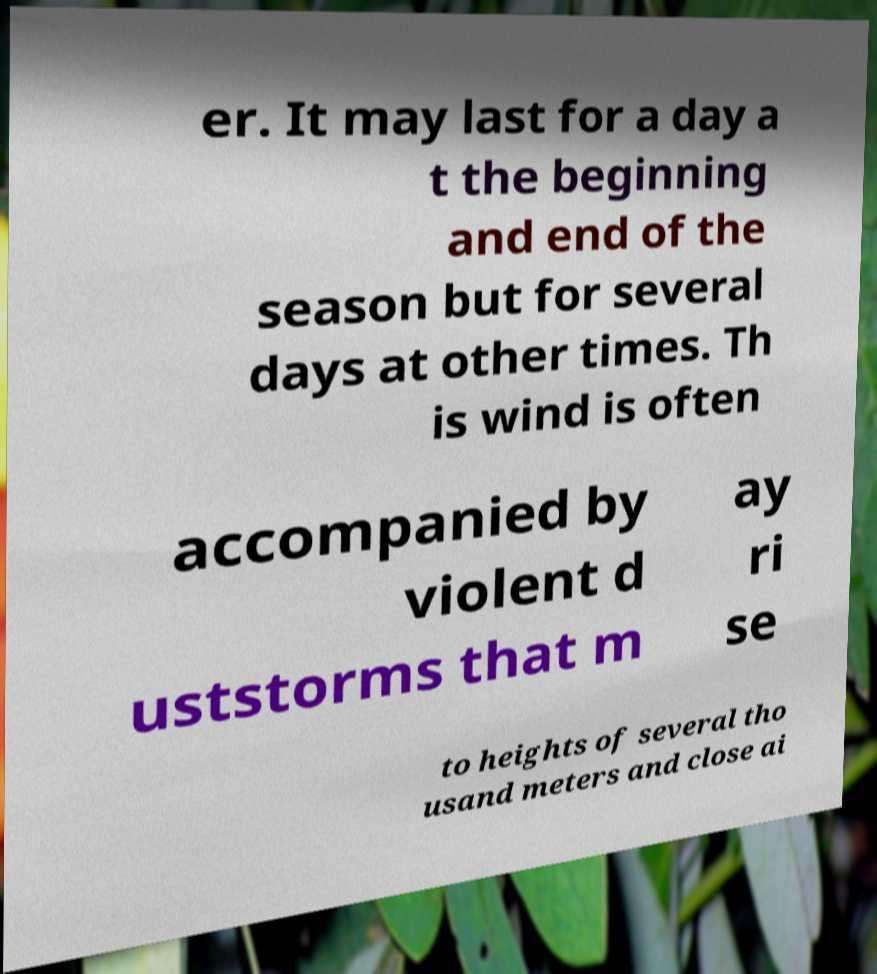Could you extract and type out the text from this image? er. It may last for a day a t the beginning and end of the season but for several days at other times. Th is wind is often accompanied by violent d uststorms that m ay ri se to heights of several tho usand meters and close ai 